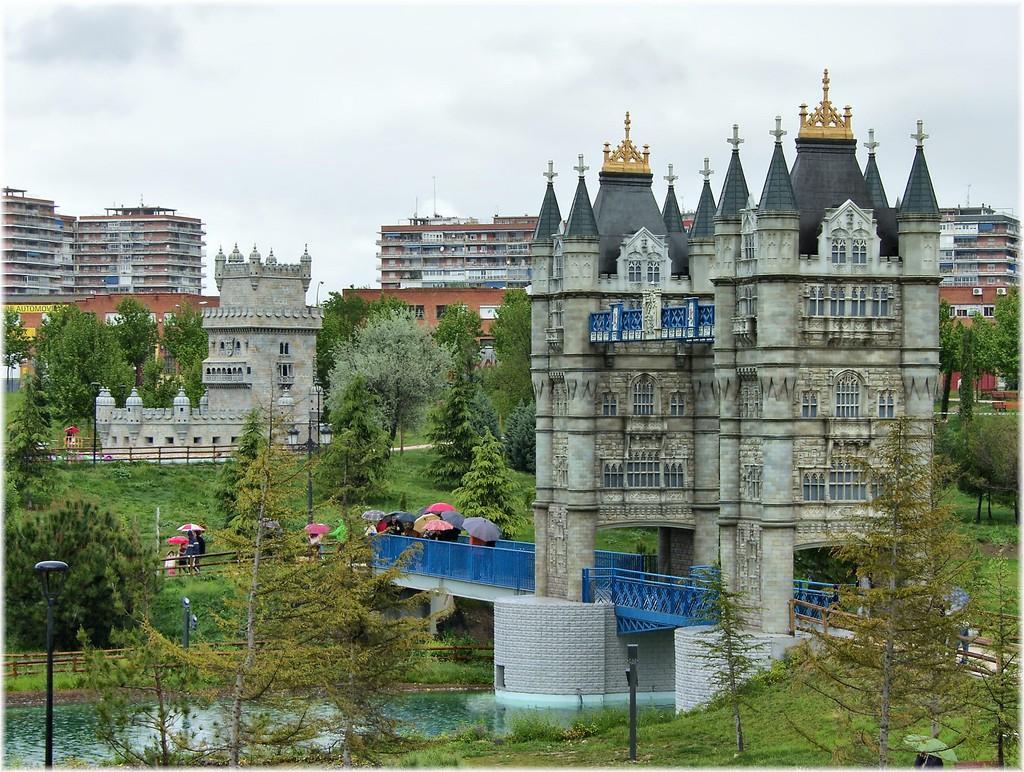How would you summarize this image in a sentence or two? In this picture we can see a bridge, under this bridge we can see water, here we can see few people and umbrellas and in the background we can see buildings, trees and the sky. 